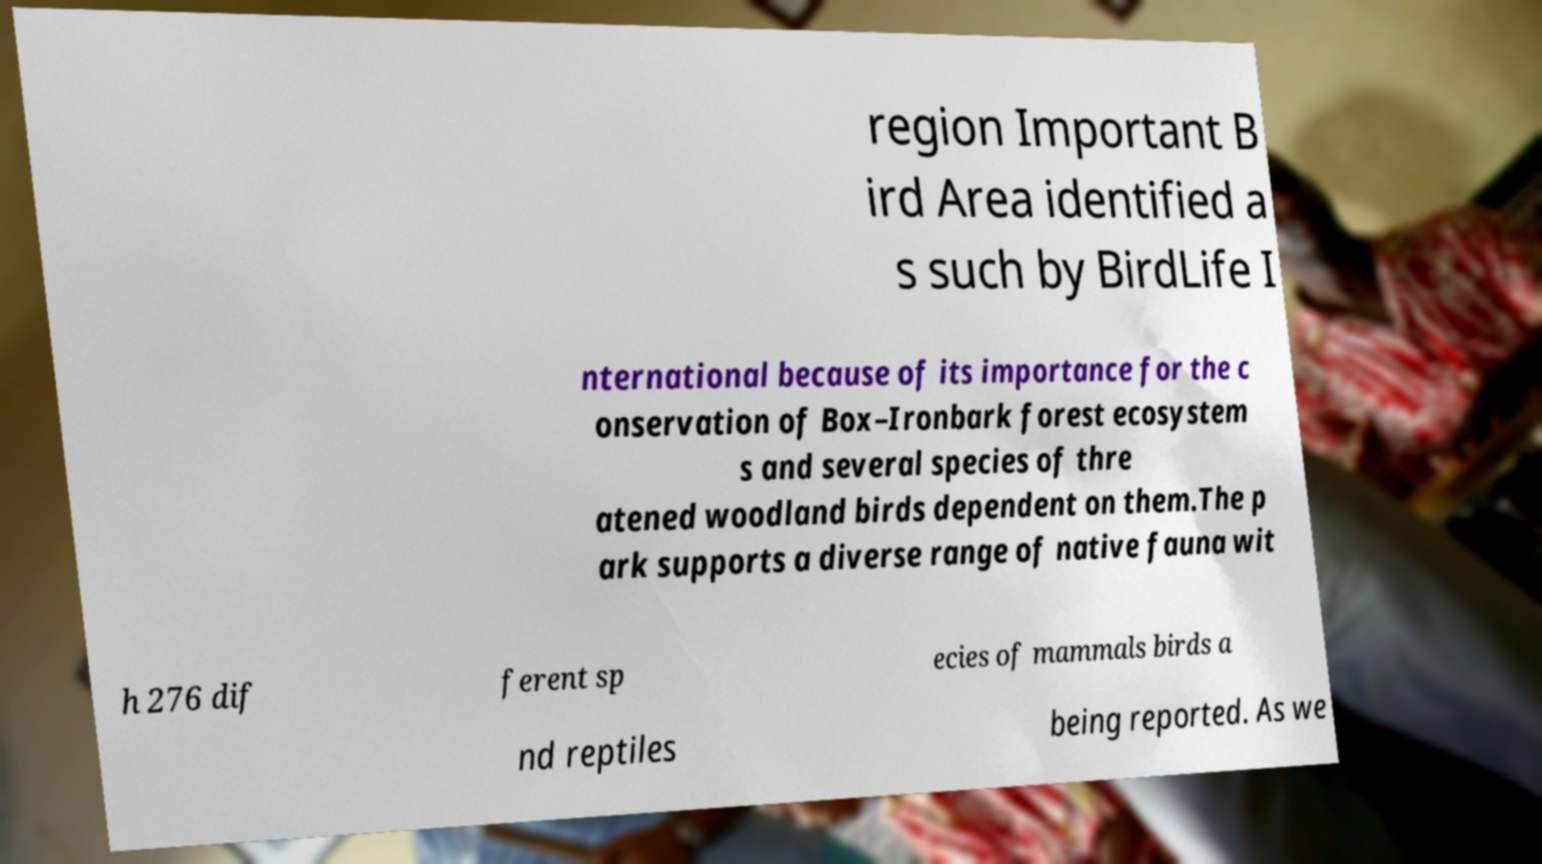Could you extract and type out the text from this image? region Important B ird Area identified a s such by BirdLife I nternational because of its importance for the c onservation of Box–Ironbark forest ecosystem s and several species of thre atened woodland birds dependent on them.The p ark supports a diverse range of native fauna wit h 276 dif ferent sp ecies of mammals birds a nd reptiles being reported. As we 